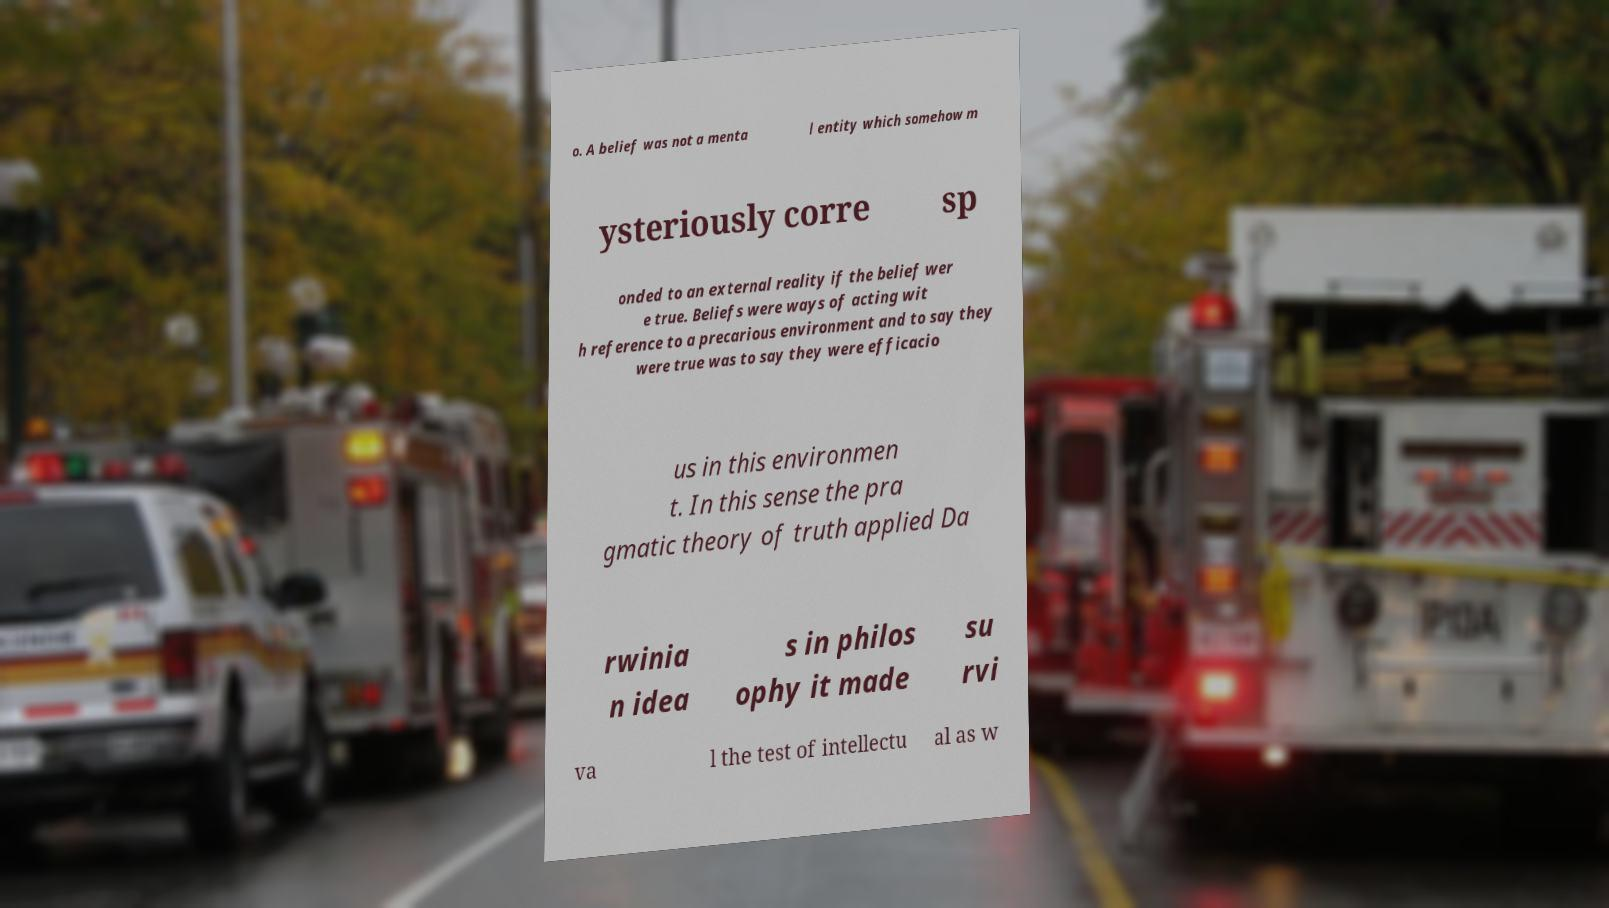Please identify and transcribe the text found in this image. o. A belief was not a menta l entity which somehow m ysteriously corre sp onded to an external reality if the belief wer e true. Beliefs were ways of acting wit h reference to a precarious environment and to say they were true was to say they were efficacio us in this environmen t. In this sense the pra gmatic theory of truth applied Da rwinia n idea s in philos ophy it made su rvi va l the test of intellectu al as w 